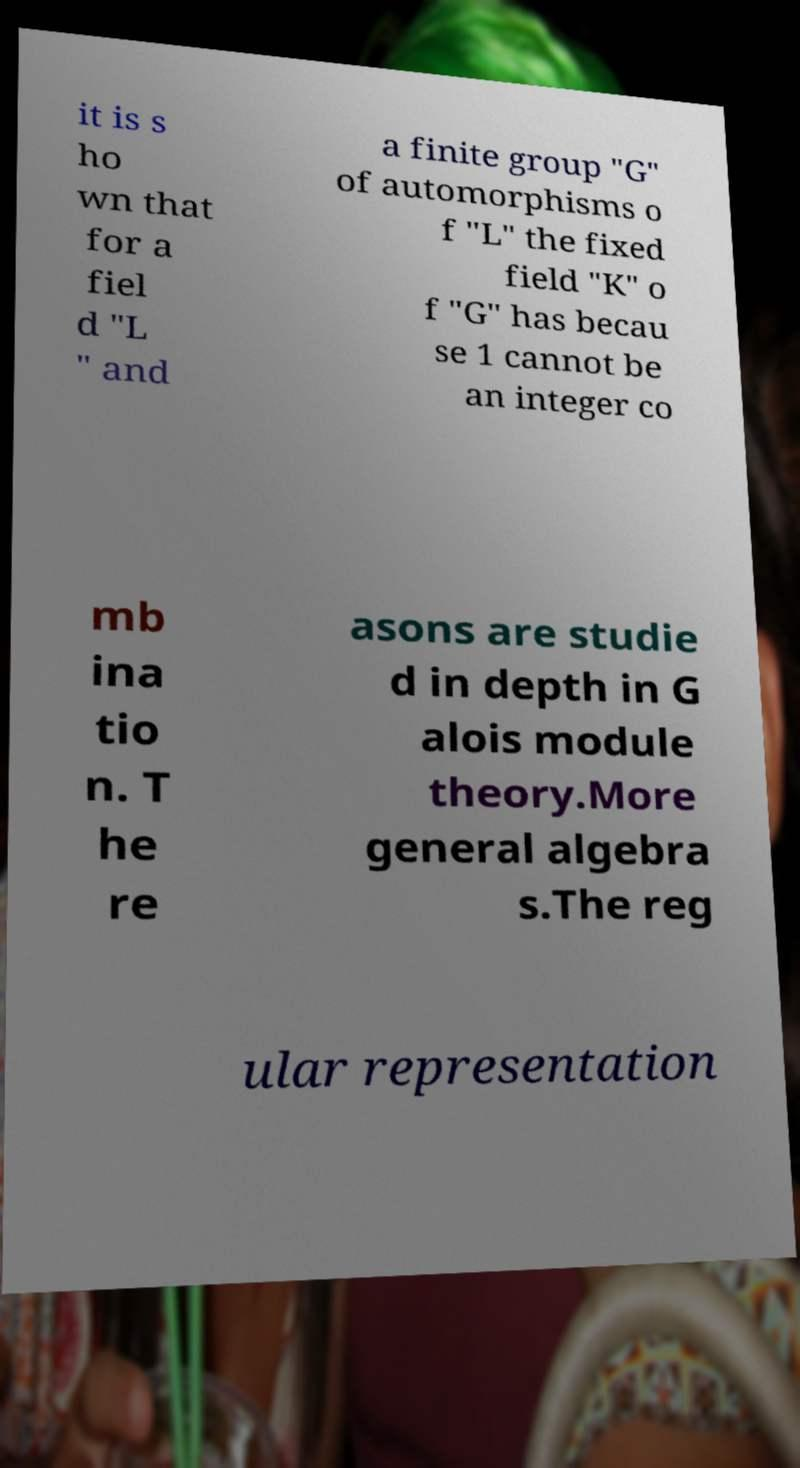Please identify and transcribe the text found in this image. it is s ho wn that for a fiel d "L " and a finite group "G" of automorphisms o f "L" the fixed field "K" o f "G" has becau se 1 cannot be an integer co mb ina tio n. T he re asons are studie d in depth in G alois module theory.More general algebra s.The reg ular representation 